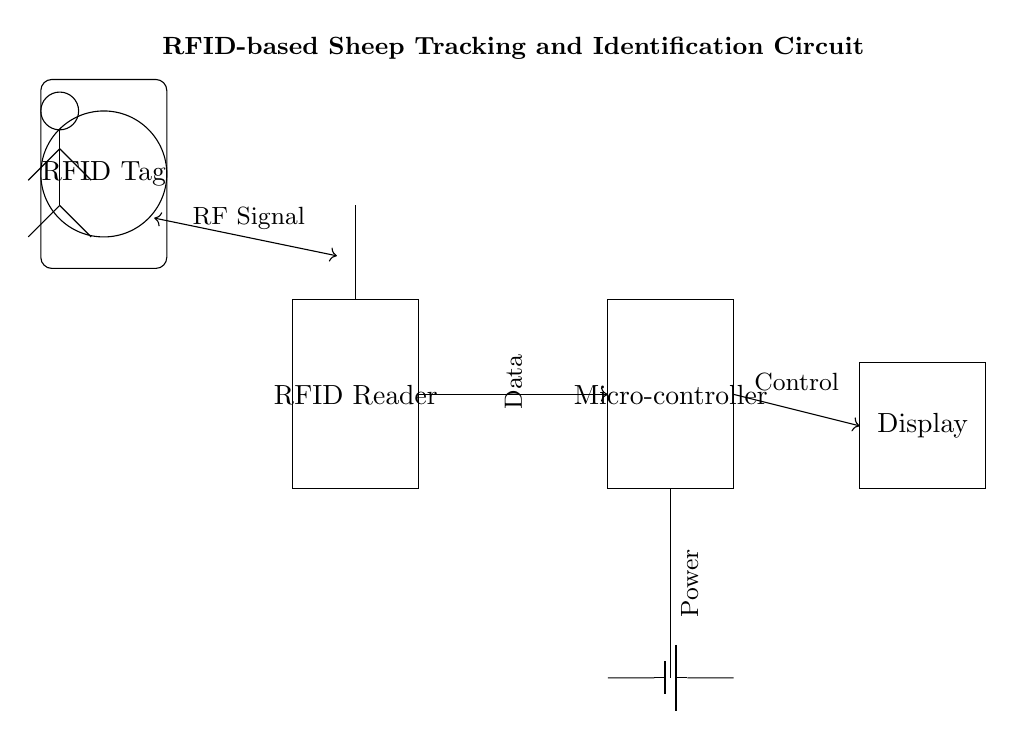What is the primary function of the RFID Reader in this circuit? The RFID Reader's primary function is to capture RF signals from RFID Tags, which enables the identification and tracking of sheep in the flock.
Answer: Capture RF signals What is the role of the Microcontroller in this circuit? The Microcontroller processes data received from the RFID Reader, making decisions and controlling the output displayed on the Display unit, thereby managing RFID data.
Answer: Process data What type of connection is shown between the RFID Reader and the Microcontroller? The connection is a data connection (indicated by an arrow) from the RFID Reader to the Microcontroller, representing the flow of data between components.
Answer: Data connection How many components are connected directly to the Battery? Two components are connected directly to the Battery: the Microcontroller and the Display, as indicated by the vertical connection from the Battery to these components.
Answer: Two What type of signal does the RFID Tag emit? The RFID Tag emits an RF Signal, which is indicated by the label connecting the tag to the RFID Reader in the circuit diagram.
Answer: RF Signal What is the purpose of the Display in this circuit? The Display shows the output from the Microcontroller, which presents relevant information based on the RFID data processed.
Answer: Show output information What does the term "Power" refer to in this context, according to the diagram? "Power" refers to the electrical supply from the Battery that powers both the Microcontroller and the Display, ensuring their functionality within the circuit.
Answer: Electrical supply 